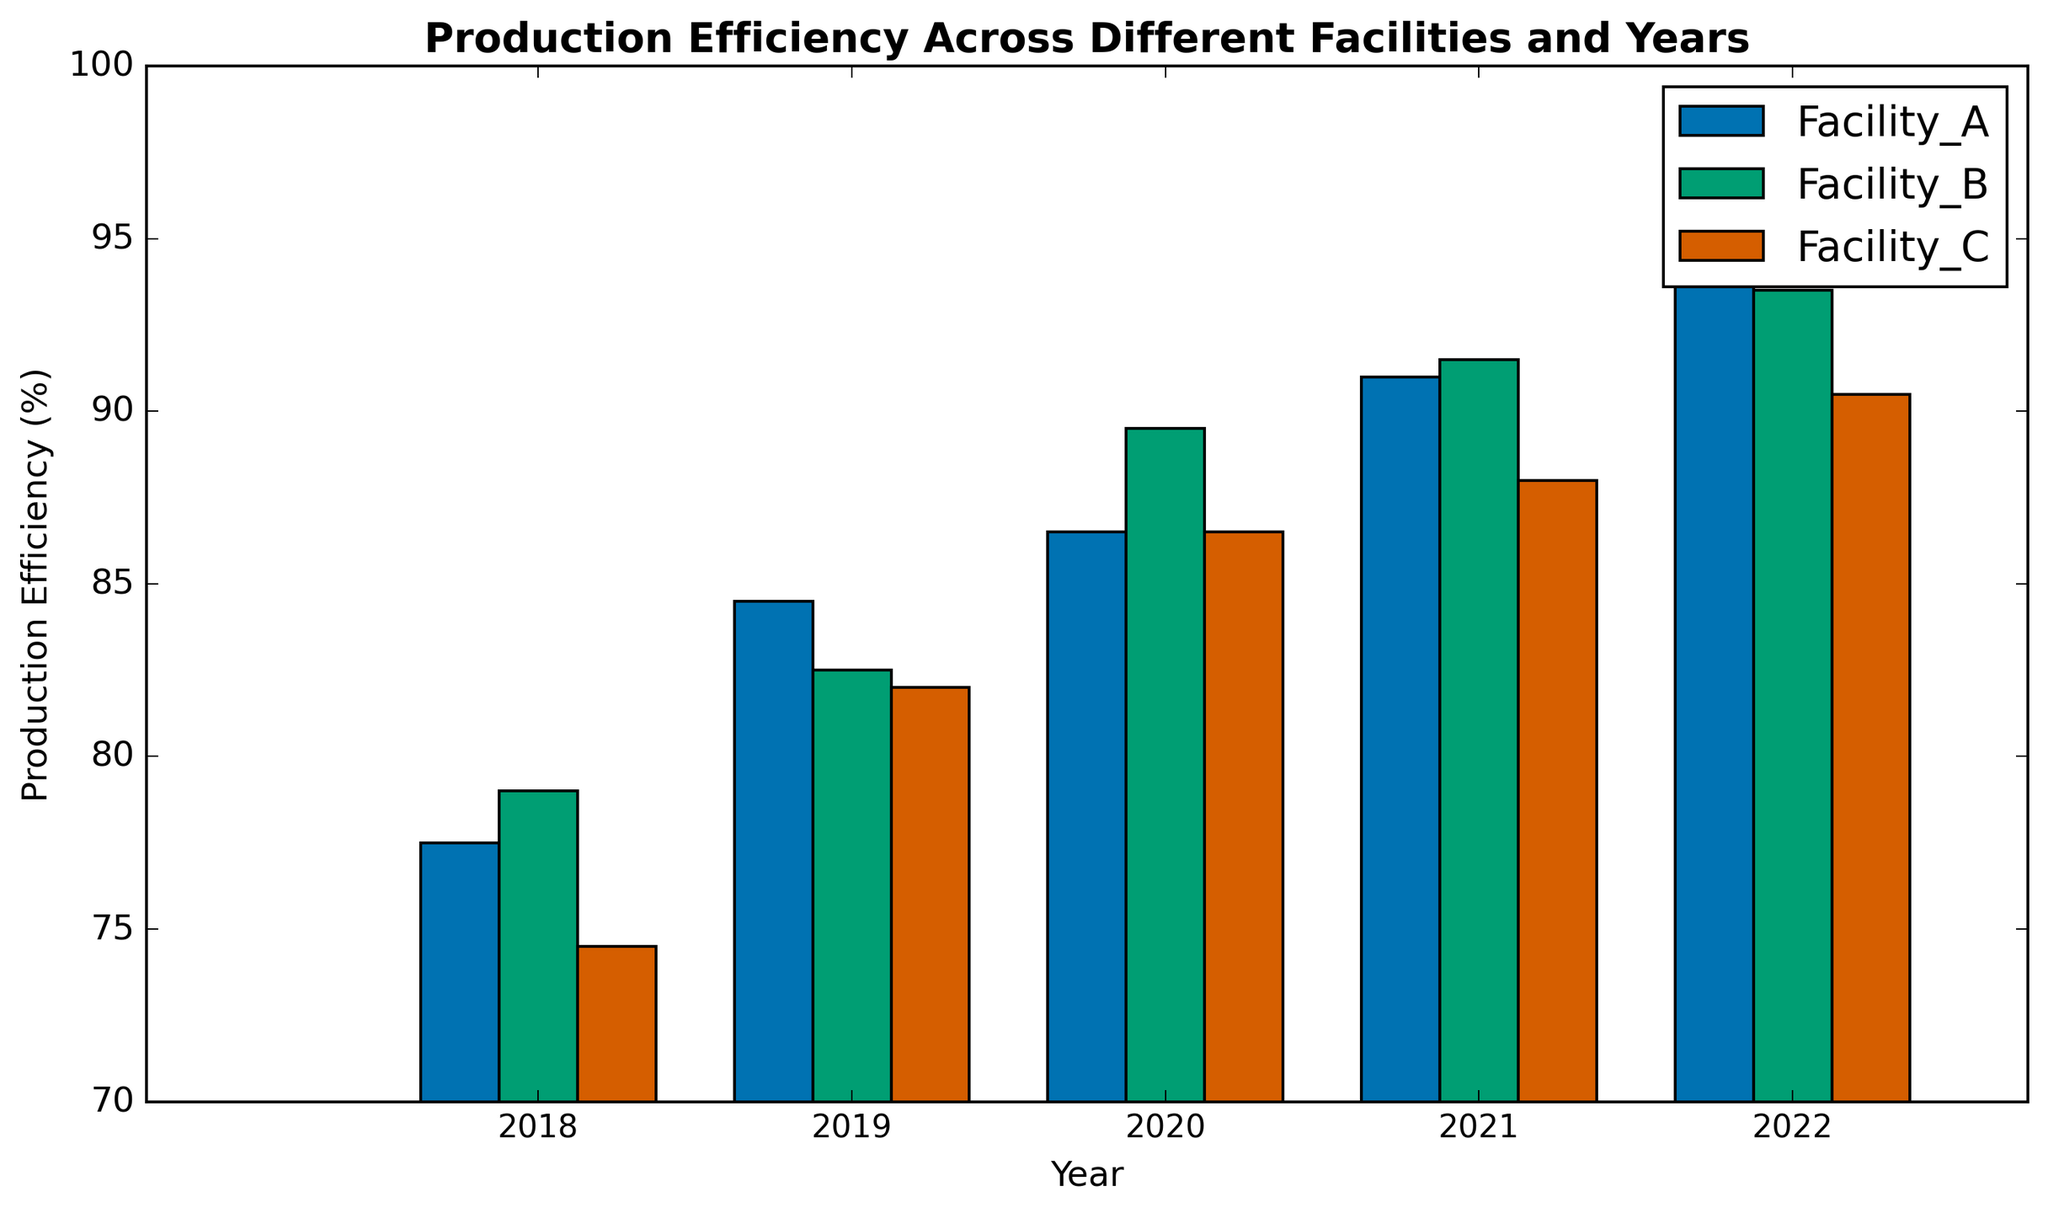What's the average production efficiency of Facility_A in 2020? First, locate the bars for Facility_A in 2020. The values are 88 and 85. Calculate the average: (88 + 85) / 2 = 173 / 2 = 86.5
Answer: 86.5 Which facility had the highest production efficiency in 2021? Look at the 2021 bars and compare their heights. Facility_A is 92, Facility_B is 91, and Facility_C is 89. Thus, the highest efficiency was achieved by Facility_A.
Answer: Facility_A Is the production efficiency of Facility_B in 2022 greater than Facility_C in 2021? Find the values: Facility_B in 2022 is 93.5 (average of 94 and 93), and Facility_C in 2021 is 88. Therefore, 93.5 > 88.
Answer: Yes What is the overall trend in production efficiency for Facility_C from 2018 to 2022? Examine Facility_C's bars from 2018 to 2022: 74.5, 82, 86.5, 88, 90.5. The trend shows a general increase over the years.
Answer: Increasing Calculate the difference in production efficiency between Facility_A and Facility_B in 2019. Locate the averages for 2019: Facility_A is 84.5 (average of 82 and 87) and Facility_B is 82.5 (average of 85 and 80). The difference is 84.5 - 82.5 = 2.
Answer: 2 Between Facility_A and Facility_B, which had less variance in production efficiency from 2018 to 2022? Compare the ranges: Facility_A varies from 75 to 95, and Facility_B varies from 78 to 94. Facility_B has a smaller range (16) compared to Facility_A's (20).
Answer: Facility_B What is the combined production efficiency of all facilities in 2020? Sum the average efficiencies for 2020: Facility_A (86.5), Facility_B (89.5), Facility_C (86.5). Total = 86.5 + 89.5 + 86.5 = 262.5.
Answer: 262.5 Did any facility have a production efficiency lower than 75% during the observed years? Look at the heights of the bars. The lowest observed efficiency is Facility_A's in 2018 which is 75. Therefore, no facility had lower than 75%.
Answer: No 